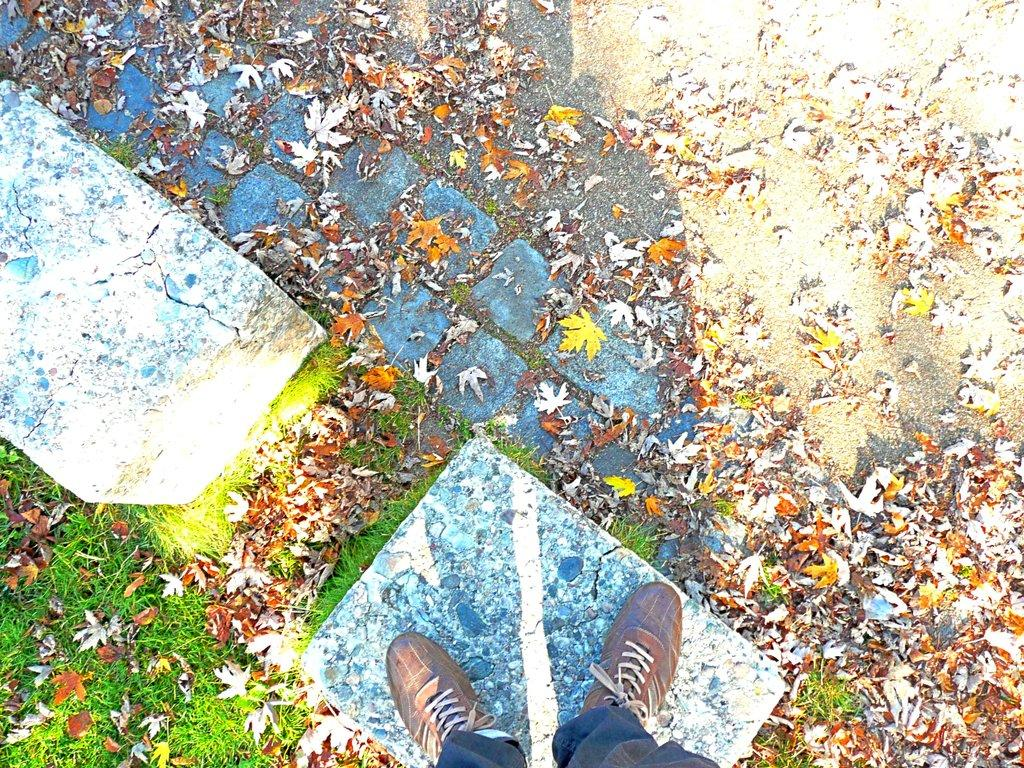What is on the ground in the image? There are dried leaves on the ground in the image. Can you describe the person in the image? There is a person in the image. What type of shoes is the person wearing? The person is wearing brown shoes. Where is the person standing in the image? The person is standing on a small pillar. What type of locket can be seen hanging from the person's neck in the image? There is no locket visible in the image; the person is not wearing any jewelry. Can you tell me how many balls are being juggled by the person in the image? There are no balls present in the image; the person is not performing any such activity. 